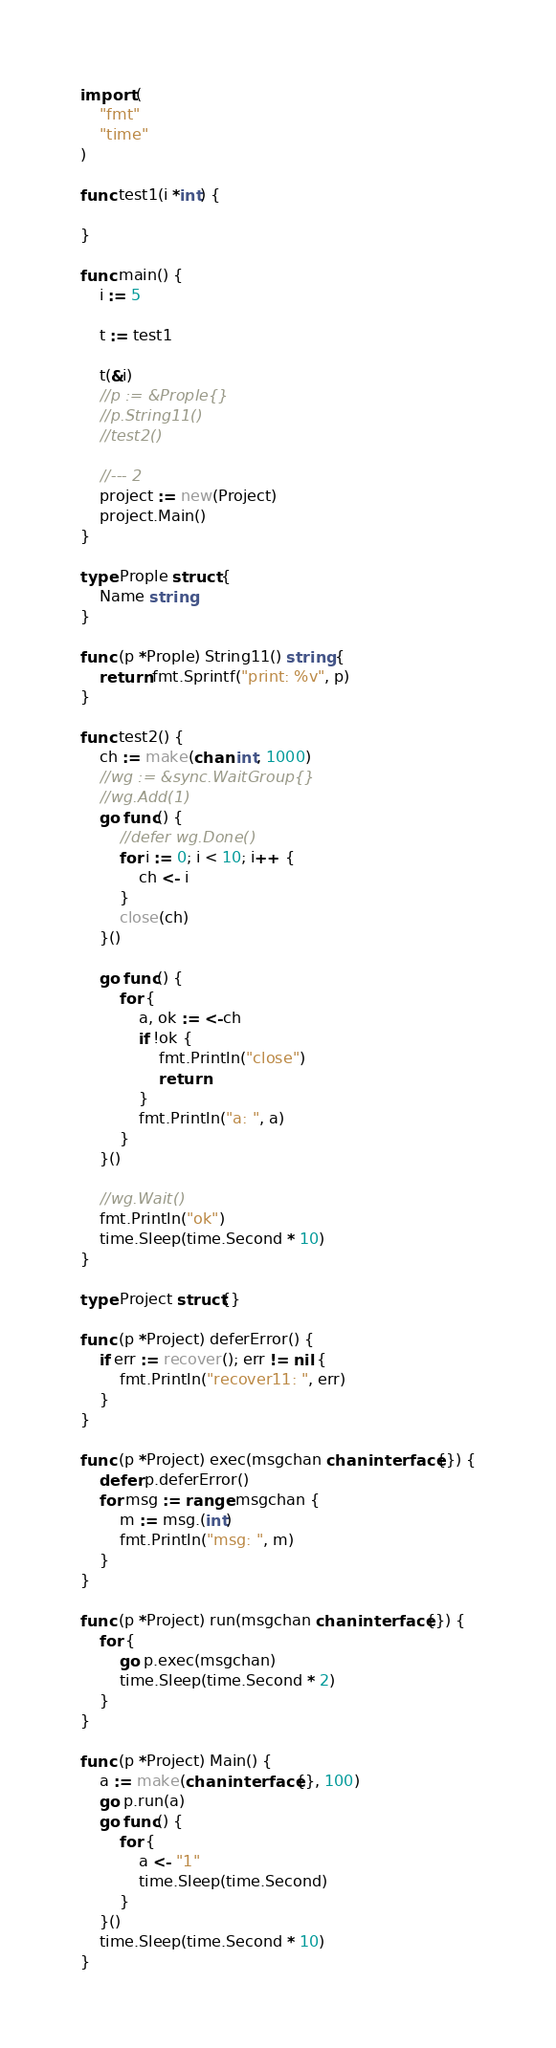<code> <loc_0><loc_0><loc_500><loc_500><_Go_>
import (
    "fmt"
    "time"
)

func test1(i *int) {

}

func main() {
    i := 5

    t := test1

    t(&i)
    //p := &Prople{}
    //p.String11()
    //test2()

    //--- 2
    project := new(Project)
    project.Main()
}

type Prople struct {
    Name string
}

func (p *Prople) String11() string {
    return fmt.Sprintf("print: %v", p)
}

func test2() {
    ch := make(chan int, 1000)
    //wg := &sync.WaitGroup{}
    //wg.Add(1)
    go func() {
        //defer wg.Done()
        for i := 0; i < 10; i++ {
            ch <- i
        }
        close(ch)
    }()

    go func() {
        for {
            a, ok := <-ch
            if !ok {
                fmt.Println("close")
                return
            }
            fmt.Println("a: ", a)
        }
    }()

    //wg.Wait()
    fmt.Println("ok")
    time.Sleep(time.Second * 10)
}

type Project struct{}

func (p *Project) deferError() {
    if err := recover(); err != nil {
        fmt.Println("recover11: ", err)
    }
}

func (p *Project) exec(msgchan chan interface{}) {
    defer p.deferError()
    for msg := range msgchan {
        m := msg.(int)
        fmt.Println("msg: ", m)
    }
}

func (p *Project) run(msgchan chan interface{}) {
    for {
        go p.exec(msgchan)
        time.Sleep(time.Second * 2)
    }
}

func (p *Project) Main() {
    a := make(chan interface{}, 100)
    go p.run(a)
    go func() {
        for {
            a <- "1"
            time.Sleep(time.Second)
        }
    }()
    time.Sleep(time.Second * 10)
}</code> 